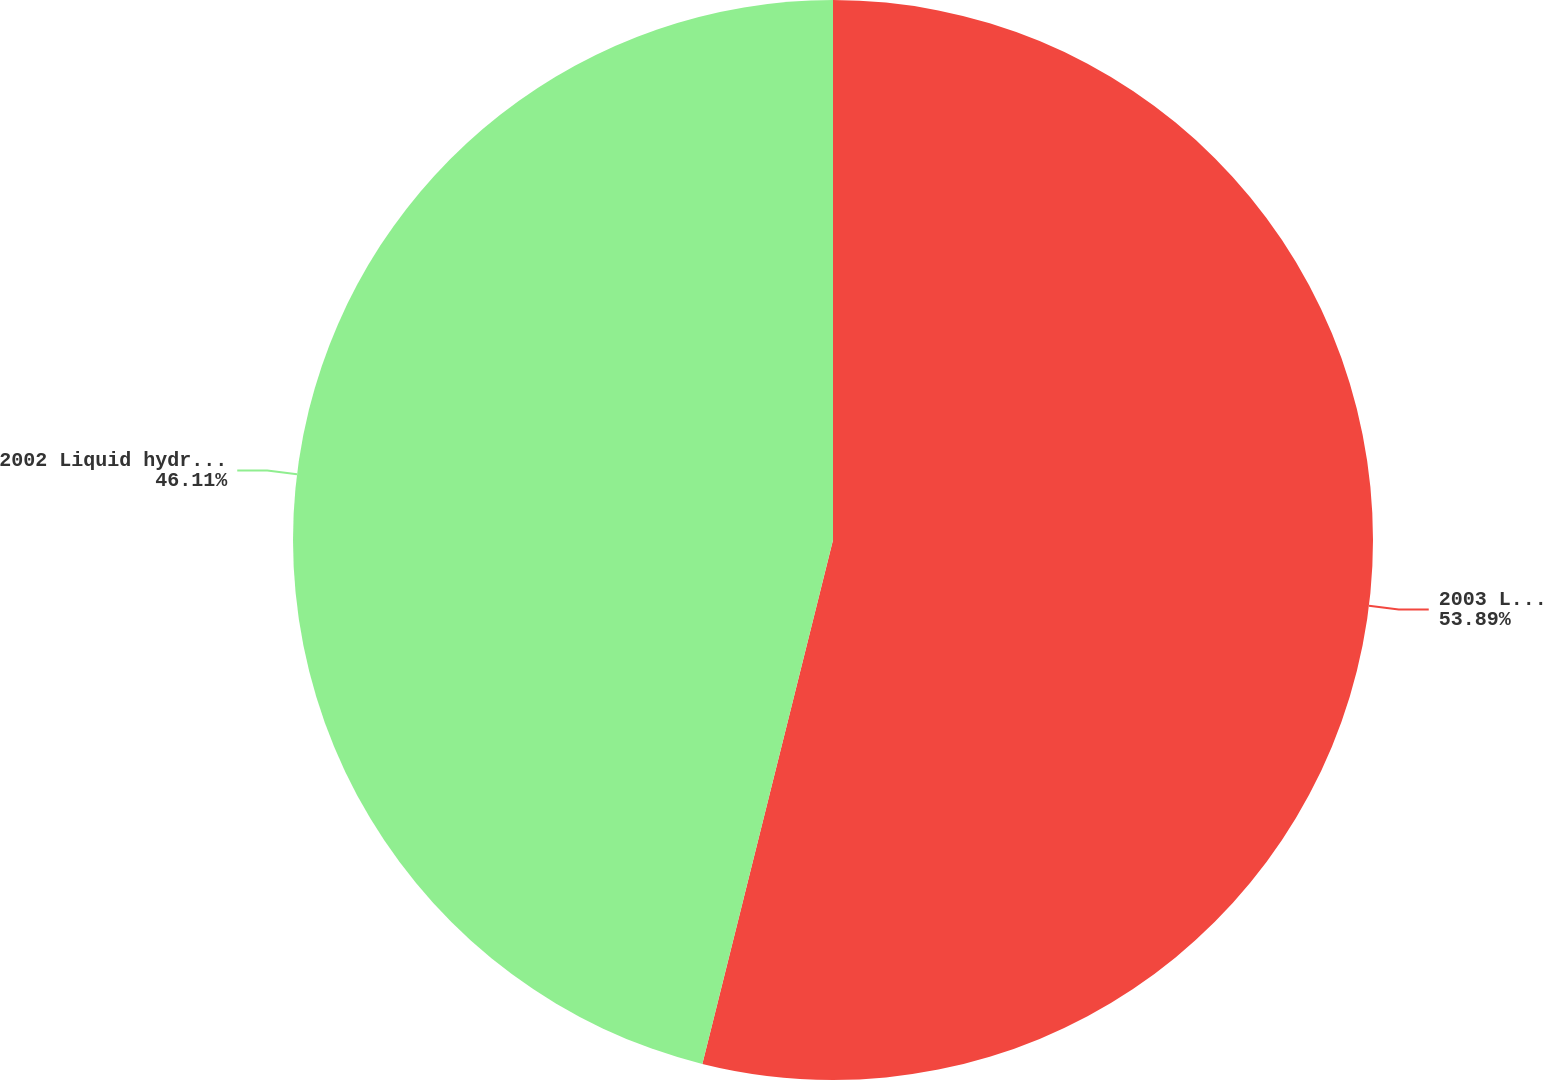Convert chart to OTSL. <chart><loc_0><loc_0><loc_500><loc_500><pie_chart><fcel>2003 Liquid hydrocarbons (per<fcel>2002 Liquid hydrocarbons (per<nl><fcel>53.89%<fcel>46.11%<nl></chart> 